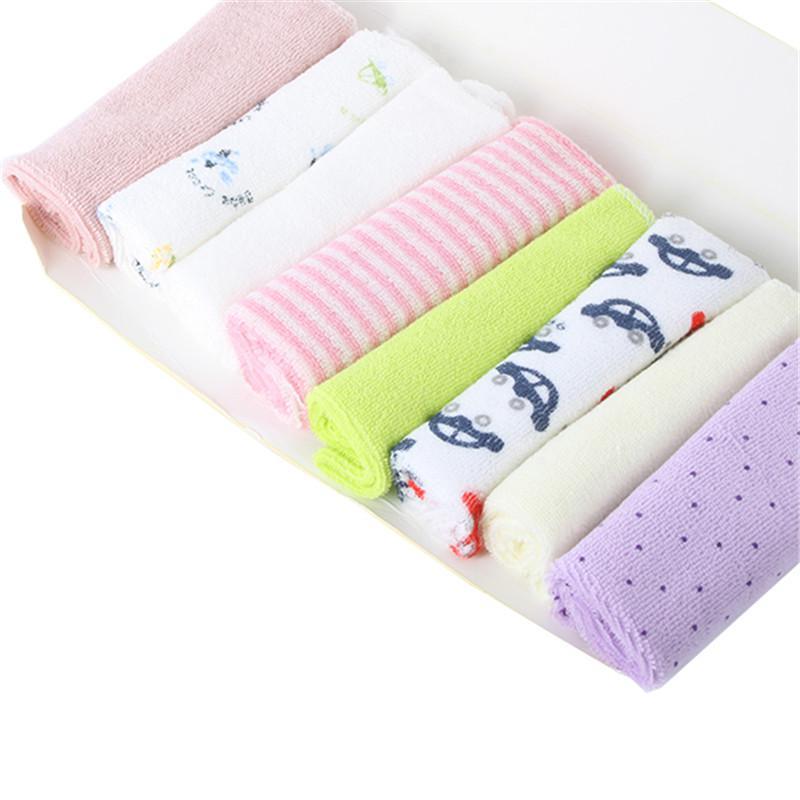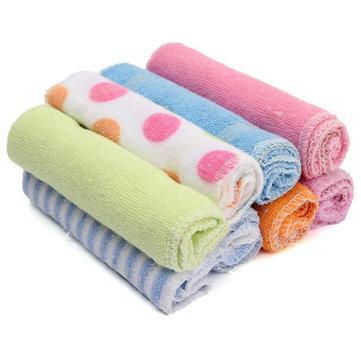The first image is the image on the left, the second image is the image on the right. Analyze the images presented: Is the assertion "There are exactly eight rolled towels." valid? Answer yes or no. No. The first image is the image on the left, the second image is the image on the right. Assess this claim about the two images: "Each image includes at least one row of folded cloth items, and one image features a package of eight rolled towels.". Correct or not? Answer yes or no. Yes. 